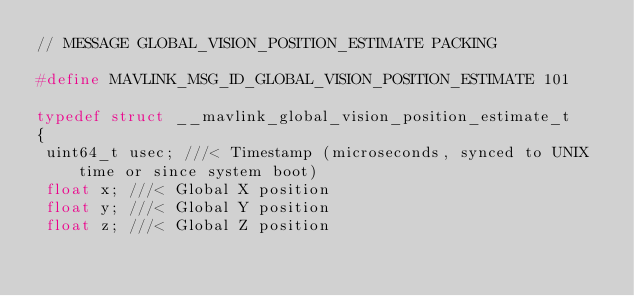Convert code to text. <code><loc_0><loc_0><loc_500><loc_500><_C_>// MESSAGE GLOBAL_VISION_POSITION_ESTIMATE PACKING

#define MAVLINK_MSG_ID_GLOBAL_VISION_POSITION_ESTIMATE 101

typedef struct __mavlink_global_vision_position_estimate_t
{
 uint64_t usec; ///< Timestamp (microseconds, synced to UNIX time or since system boot)
 float x; ///< Global X position
 float y; ///< Global Y position
 float z; ///< Global Z position</code> 